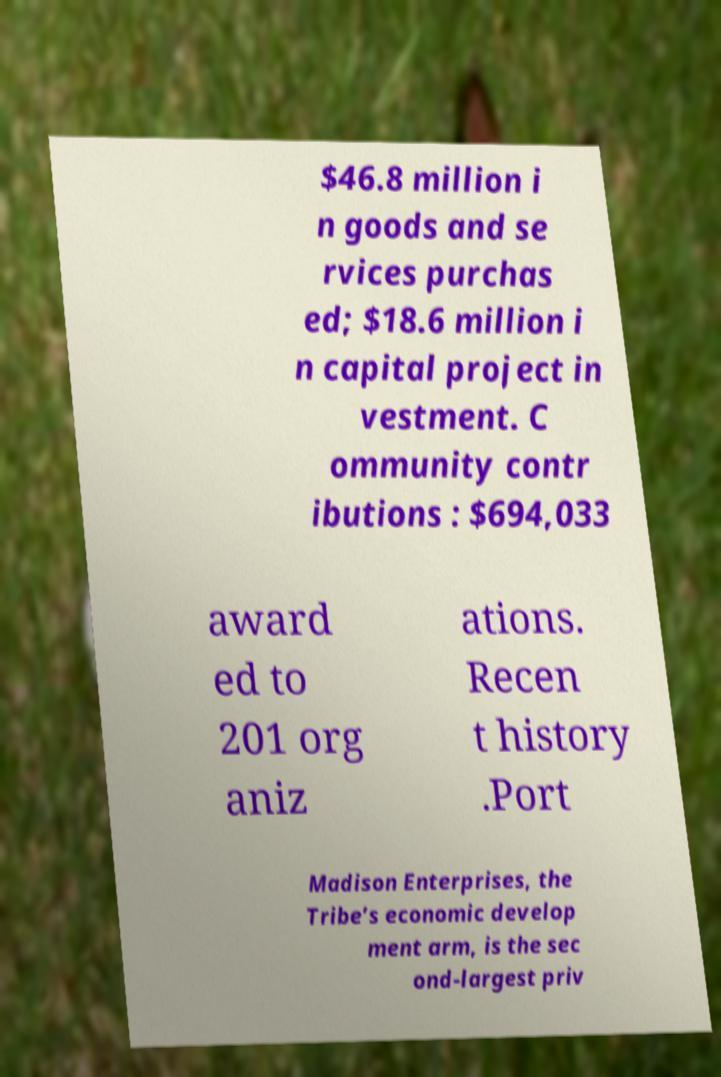Could you assist in decoding the text presented in this image and type it out clearly? $46.8 million i n goods and se rvices purchas ed; $18.6 million i n capital project in vestment. C ommunity contr ibutions : $694,033 award ed to 201 org aniz ations. Recen t history .Port Madison Enterprises, the Tribe’s economic develop ment arm, is the sec ond-largest priv 